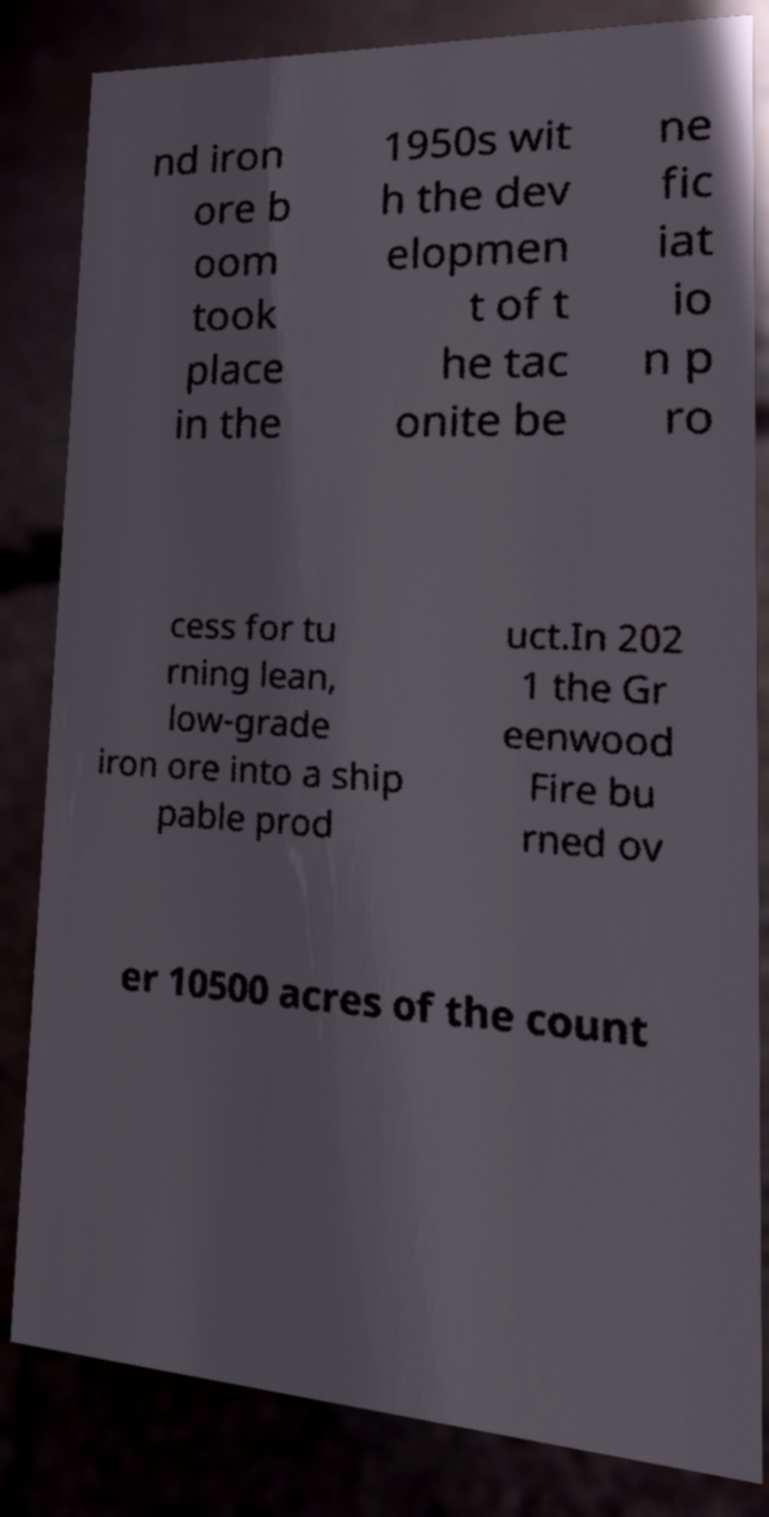Can you read and provide the text displayed in the image?This photo seems to have some interesting text. Can you extract and type it out for me? nd iron ore b oom took place in the 1950s wit h the dev elopmen t of t he tac onite be ne fic iat io n p ro cess for tu rning lean, low-grade iron ore into a ship pable prod uct.In 202 1 the Gr eenwood Fire bu rned ov er 10500 acres of the count 